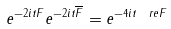<formula> <loc_0><loc_0><loc_500><loc_500>e ^ { - 2 i t F } e ^ { - 2 i t \overline { F } } = e ^ { - 4 i t \ r e F }</formula> 